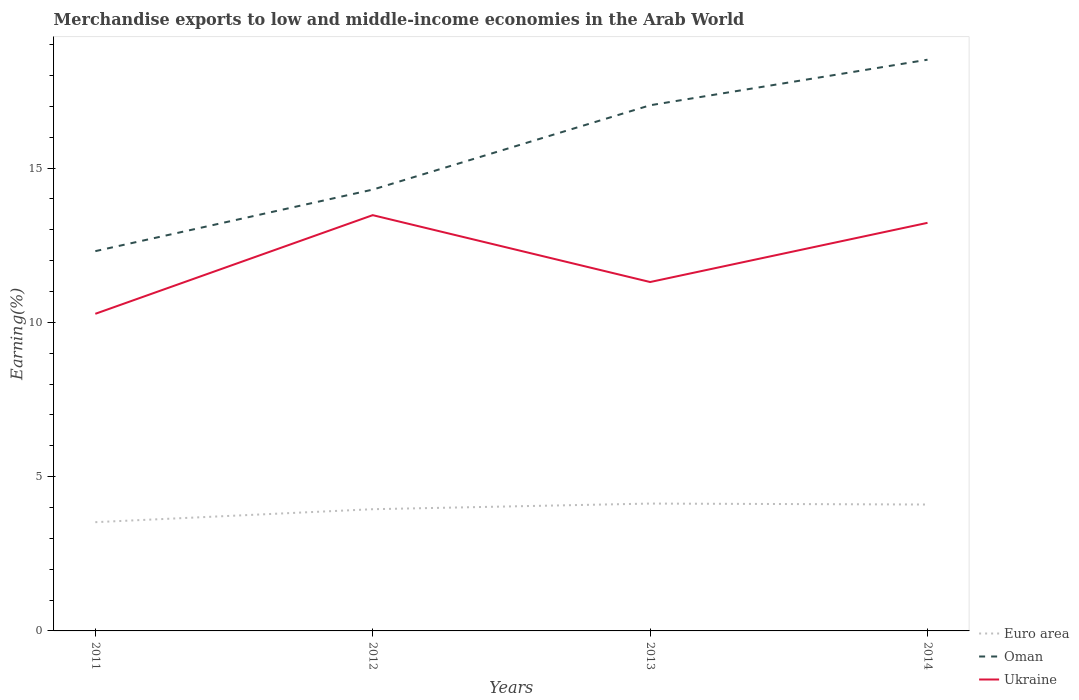How many different coloured lines are there?
Your answer should be very brief. 3. Does the line corresponding to Ukraine intersect with the line corresponding to Euro area?
Keep it short and to the point. No. Across all years, what is the maximum percentage of amount earned from merchandise exports in Oman?
Offer a terse response. 12.31. What is the total percentage of amount earned from merchandise exports in Euro area in the graph?
Your answer should be compact. -0.15. What is the difference between the highest and the second highest percentage of amount earned from merchandise exports in Oman?
Your answer should be compact. 6.2. Are the values on the major ticks of Y-axis written in scientific E-notation?
Your answer should be compact. No. Does the graph contain any zero values?
Your response must be concise. No. Does the graph contain grids?
Keep it short and to the point. No. Where does the legend appear in the graph?
Give a very brief answer. Bottom right. How many legend labels are there?
Your answer should be compact. 3. How are the legend labels stacked?
Your answer should be very brief. Vertical. What is the title of the graph?
Make the answer very short. Merchandise exports to low and middle-income economies in the Arab World. Does "India" appear as one of the legend labels in the graph?
Your answer should be compact. No. What is the label or title of the X-axis?
Provide a short and direct response. Years. What is the label or title of the Y-axis?
Offer a very short reply. Earning(%). What is the Earning(%) of Euro area in 2011?
Provide a succinct answer. 3.52. What is the Earning(%) of Oman in 2011?
Your answer should be very brief. 12.31. What is the Earning(%) in Ukraine in 2011?
Provide a succinct answer. 10.28. What is the Earning(%) in Euro area in 2012?
Ensure brevity in your answer.  3.94. What is the Earning(%) in Oman in 2012?
Keep it short and to the point. 14.3. What is the Earning(%) of Ukraine in 2012?
Keep it short and to the point. 13.47. What is the Earning(%) in Euro area in 2013?
Ensure brevity in your answer.  4.13. What is the Earning(%) in Oman in 2013?
Make the answer very short. 17.04. What is the Earning(%) of Ukraine in 2013?
Provide a short and direct response. 11.31. What is the Earning(%) in Euro area in 2014?
Give a very brief answer. 4.1. What is the Earning(%) in Oman in 2014?
Provide a short and direct response. 18.51. What is the Earning(%) of Ukraine in 2014?
Provide a succinct answer. 13.23. Across all years, what is the maximum Earning(%) of Euro area?
Offer a terse response. 4.13. Across all years, what is the maximum Earning(%) of Oman?
Provide a short and direct response. 18.51. Across all years, what is the maximum Earning(%) in Ukraine?
Make the answer very short. 13.47. Across all years, what is the minimum Earning(%) of Euro area?
Your answer should be very brief. 3.52. Across all years, what is the minimum Earning(%) in Oman?
Your answer should be very brief. 12.31. Across all years, what is the minimum Earning(%) in Ukraine?
Your answer should be very brief. 10.28. What is the total Earning(%) of Euro area in the graph?
Your answer should be very brief. 15.69. What is the total Earning(%) in Oman in the graph?
Offer a very short reply. 62.16. What is the total Earning(%) in Ukraine in the graph?
Provide a succinct answer. 48.29. What is the difference between the Earning(%) of Euro area in 2011 and that in 2012?
Provide a short and direct response. -0.42. What is the difference between the Earning(%) in Oman in 2011 and that in 2012?
Offer a terse response. -1.99. What is the difference between the Earning(%) of Ukraine in 2011 and that in 2012?
Your answer should be compact. -3.2. What is the difference between the Earning(%) in Euro area in 2011 and that in 2013?
Give a very brief answer. -0.6. What is the difference between the Earning(%) of Oman in 2011 and that in 2013?
Give a very brief answer. -4.73. What is the difference between the Earning(%) in Ukraine in 2011 and that in 2013?
Make the answer very short. -1.03. What is the difference between the Earning(%) of Euro area in 2011 and that in 2014?
Offer a very short reply. -0.57. What is the difference between the Earning(%) of Oman in 2011 and that in 2014?
Offer a very short reply. -6.2. What is the difference between the Earning(%) of Ukraine in 2011 and that in 2014?
Keep it short and to the point. -2.95. What is the difference between the Earning(%) of Euro area in 2012 and that in 2013?
Offer a terse response. -0.18. What is the difference between the Earning(%) in Oman in 2012 and that in 2013?
Offer a very short reply. -2.73. What is the difference between the Earning(%) in Ukraine in 2012 and that in 2013?
Provide a succinct answer. 2.17. What is the difference between the Earning(%) of Euro area in 2012 and that in 2014?
Provide a short and direct response. -0.15. What is the difference between the Earning(%) in Oman in 2012 and that in 2014?
Give a very brief answer. -4.21. What is the difference between the Earning(%) in Ukraine in 2012 and that in 2014?
Keep it short and to the point. 0.25. What is the difference between the Earning(%) of Euro area in 2013 and that in 2014?
Your answer should be very brief. 0.03. What is the difference between the Earning(%) of Oman in 2013 and that in 2014?
Keep it short and to the point. -1.48. What is the difference between the Earning(%) of Ukraine in 2013 and that in 2014?
Keep it short and to the point. -1.92. What is the difference between the Earning(%) in Euro area in 2011 and the Earning(%) in Oman in 2012?
Keep it short and to the point. -10.78. What is the difference between the Earning(%) in Euro area in 2011 and the Earning(%) in Ukraine in 2012?
Offer a very short reply. -9.95. What is the difference between the Earning(%) of Oman in 2011 and the Earning(%) of Ukraine in 2012?
Make the answer very short. -1.17. What is the difference between the Earning(%) of Euro area in 2011 and the Earning(%) of Oman in 2013?
Offer a terse response. -13.51. What is the difference between the Earning(%) of Euro area in 2011 and the Earning(%) of Ukraine in 2013?
Your response must be concise. -7.78. What is the difference between the Earning(%) in Oman in 2011 and the Earning(%) in Ukraine in 2013?
Make the answer very short. 1. What is the difference between the Earning(%) in Euro area in 2011 and the Earning(%) in Oman in 2014?
Give a very brief answer. -14.99. What is the difference between the Earning(%) of Euro area in 2011 and the Earning(%) of Ukraine in 2014?
Make the answer very short. -9.7. What is the difference between the Earning(%) of Oman in 2011 and the Earning(%) of Ukraine in 2014?
Your response must be concise. -0.92. What is the difference between the Earning(%) in Euro area in 2012 and the Earning(%) in Oman in 2013?
Your answer should be very brief. -13.09. What is the difference between the Earning(%) of Euro area in 2012 and the Earning(%) of Ukraine in 2013?
Give a very brief answer. -7.36. What is the difference between the Earning(%) in Oman in 2012 and the Earning(%) in Ukraine in 2013?
Keep it short and to the point. 2.99. What is the difference between the Earning(%) of Euro area in 2012 and the Earning(%) of Oman in 2014?
Your answer should be compact. -14.57. What is the difference between the Earning(%) in Euro area in 2012 and the Earning(%) in Ukraine in 2014?
Provide a succinct answer. -9.28. What is the difference between the Earning(%) in Oman in 2012 and the Earning(%) in Ukraine in 2014?
Your response must be concise. 1.08. What is the difference between the Earning(%) of Euro area in 2013 and the Earning(%) of Oman in 2014?
Provide a succinct answer. -14.39. What is the difference between the Earning(%) in Euro area in 2013 and the Earning(%) in Ukraine in 2014?
Your response must be concise. -9.1. What is the difference between the Earning(%) of Oman in 2013 and the Earning(%) of Ukraine in 2014?
Your response must be concise. 3.81. What is the average Earning(%) of Euro area per year?
Ensure brevity in your answer.  3.92. What is the average Earning(%) of Oman per year?
Offer a very short reply. 15.54. What is the average Earning(%) of Ukraine per year?
Offer a terse response. 12.07. In the year 2011, what is the difference between the Earning(%) in Euro area and Earning(%) in Oman?
Offer a very short reply. -8.78. In the year 2011, what is the difference between the Earning(%) of Euro area and Earning(%) of Ukraine?
Provide a succinct answer. -6.75. In the year 2011, what is the difference between the Earning(%) of Oman and Earning(%) of Ukraine?
Make the answer very short. 2.03. In the year 2012, what is the difference between the Earning(%) in Euro area and Earning(%) in Oman?
Offer a very short reply. -10.36. In the year 2012, what is the difference between the Earning(%) in Euro area and Earning(%) in Ukraine?
Keep it short and to the point. -9.53. In the year 2012, what is the difference between the Earning(%) in Oman and Earning(%) in Ukraine?
Your answer should be compact. 0.83. In the year 2013, what is the difference between the Earning(%) of Euro area and Earning(%) of Oman?
Provide a succinct answer. -12.91. In the year 2013, what is the difference between the Earning(%) of Euro area and Earning(%) of Ukraine?
Offer a very short reply. -7.18. In the year 2013, what is the difference between the Earning(%) in Oman and Earning(%) in Ukraine?
Provide a short and direct response. 5.73. In the year 2014, what is the difference between the Earning(%) in Euro area and Earning(%) in Oman?
Offer a terse response. -14.42. In the year 2014, what is the difference between the Earning(%) in Euro area and Earning(%) in Ukraine?
Your answer should be compact. -9.13. In the year 2014, what is the difference between the Earning(%) in Oman and Earning(%) in Ukraine?
Ensure brevity in your answer.  5.29. What is the ratio of the Earning(%) in Euro area in 2011 to that in 2012?
Offer a terse response. 0.89. What is the ratio of the Earning(%) of Oman in 2011 to that in 2012?
Provide a short and direct response. 0.86. What is the ratio of the Earning(%) of Ukraine in 2011 to that in 2012?
Give a very brief answer. 0.76. What is the ratio of the Earning(%) in Euro area in 2011 to that in 2013?
Your response must be concise. 0.85. What is the ratio of the Earning(%) of Oman in 2011 to that in 2013?
Provide a short and direct response. 0.72. What is the ratio of the Earning(%) of Ukraine in 2011 to that in 2013?
Your answer should be very brief. 0.91. What is the ratio of the Earning(%) of Euro area in 2011 to that in 2014?
Ensure brevity in your answer.  0.86. What is the ratio of the Earning(%) of Oman in 2011 to that in 2014?
Your response must be concise. 0.66. What is the ratio of the Earning(%) in Ukraine in 2011 to that in 2014?
Offer a very short reply. 0.78. What is the ratio of the Earning(%) in Euro area in 2012 to that in 2013?
Provide a short and direct response. 0.96. What is the ratio of the Earning(%) of Oman in 2012 to that in 2013?
Your answer should be very brief. 0.84. What is the ratio of the Earning(%) in Ukraine in 2012 to that in 2013?
Provide a succinct answer. 1.19. What is the ratio of the Earning(%) in Oman in 2012 to that in 2014?
Offer a terse response. 0.77. What is the ratio of the Earning(%) in Ukraine in 2012 to that in 2014?
Give a very brief answer. 1.02. What is the ratio of the Earning(%) in Euro area in 2013 to that in 2014?
Your answer should be very brief. 1.01. What is the ratio of the Earning(%) in Oman in 2013 to that in 2014?
Keep it short and to the point. 0.92. What is the ratio of the Earning(%) in Ukraine in 2013 to that in 2014?
Your answer should be very brief. 0.85. What is the difference between the highest and the second highest Earning(%) of Euro area?
Your response must be concise. 0.03. What is the difference between the highest and the second highest Earning(%) in Oman?
Provide a succinct answer. 1.48. What is the difference between the highest and the second highest Earning(%) of Ukraine?
Provide a succinct answer. 0.25. What is the difference between the highest and the lowest Earning(%) of Euro area?
Make the answer very short. 0.6. What is the difference between the highest and the lowest Earning(%) of Oman?
Make the answer very short. 6.2. What is the difference between the highest and the lowest Earning(%) in Ukraine?
Make the answer very short. 3.2. 